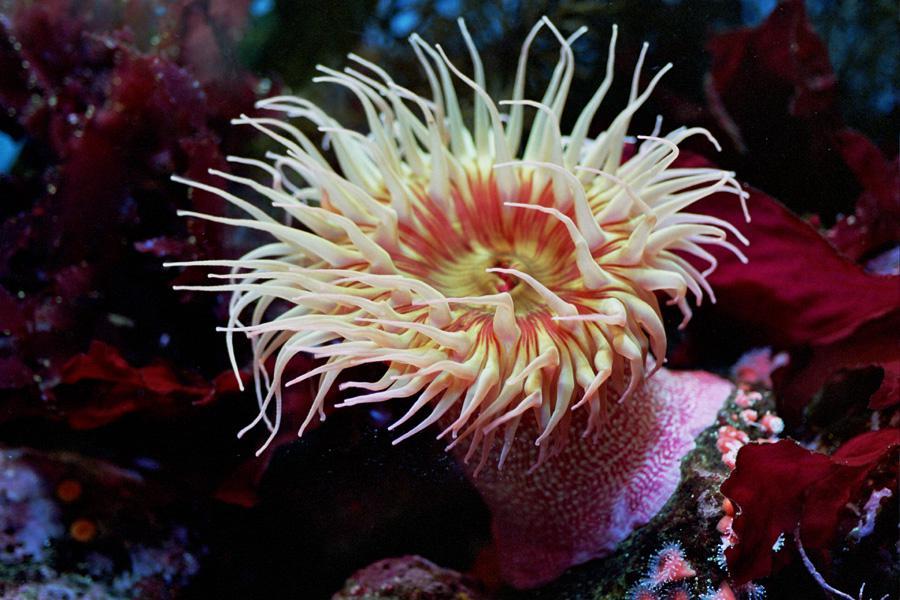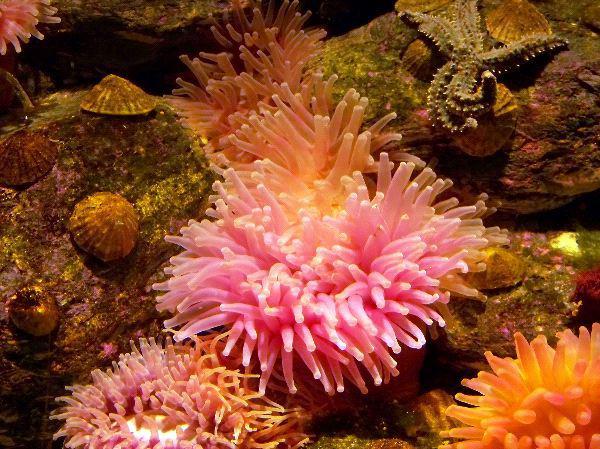The first image is the image on the left, the second image is the image on the right. Evaluate the accuracy of this statement regarding the images: "There are more sea plants in the image on the left than in the image on the right.". Is it true? Answer yes or no. No. The first image is the image on the left, the second image is the image on the right. Examine the images to the left and right. Is the description "An image shows the spotted pink stalk of one anemone." accurate? Answer yes or no. Yes. 